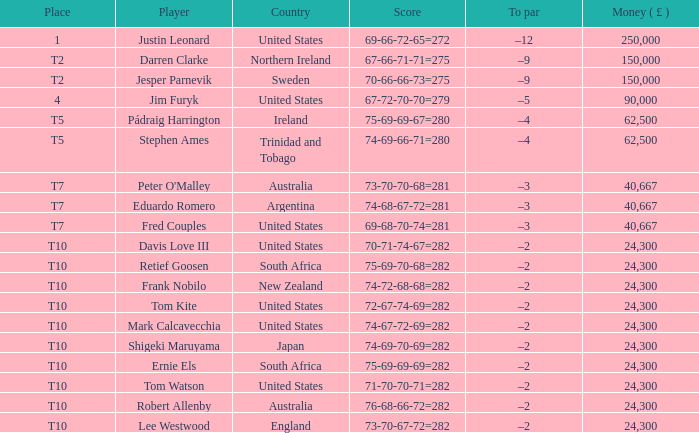How much money has frank nobilo earned from his winnings? 1.0. 